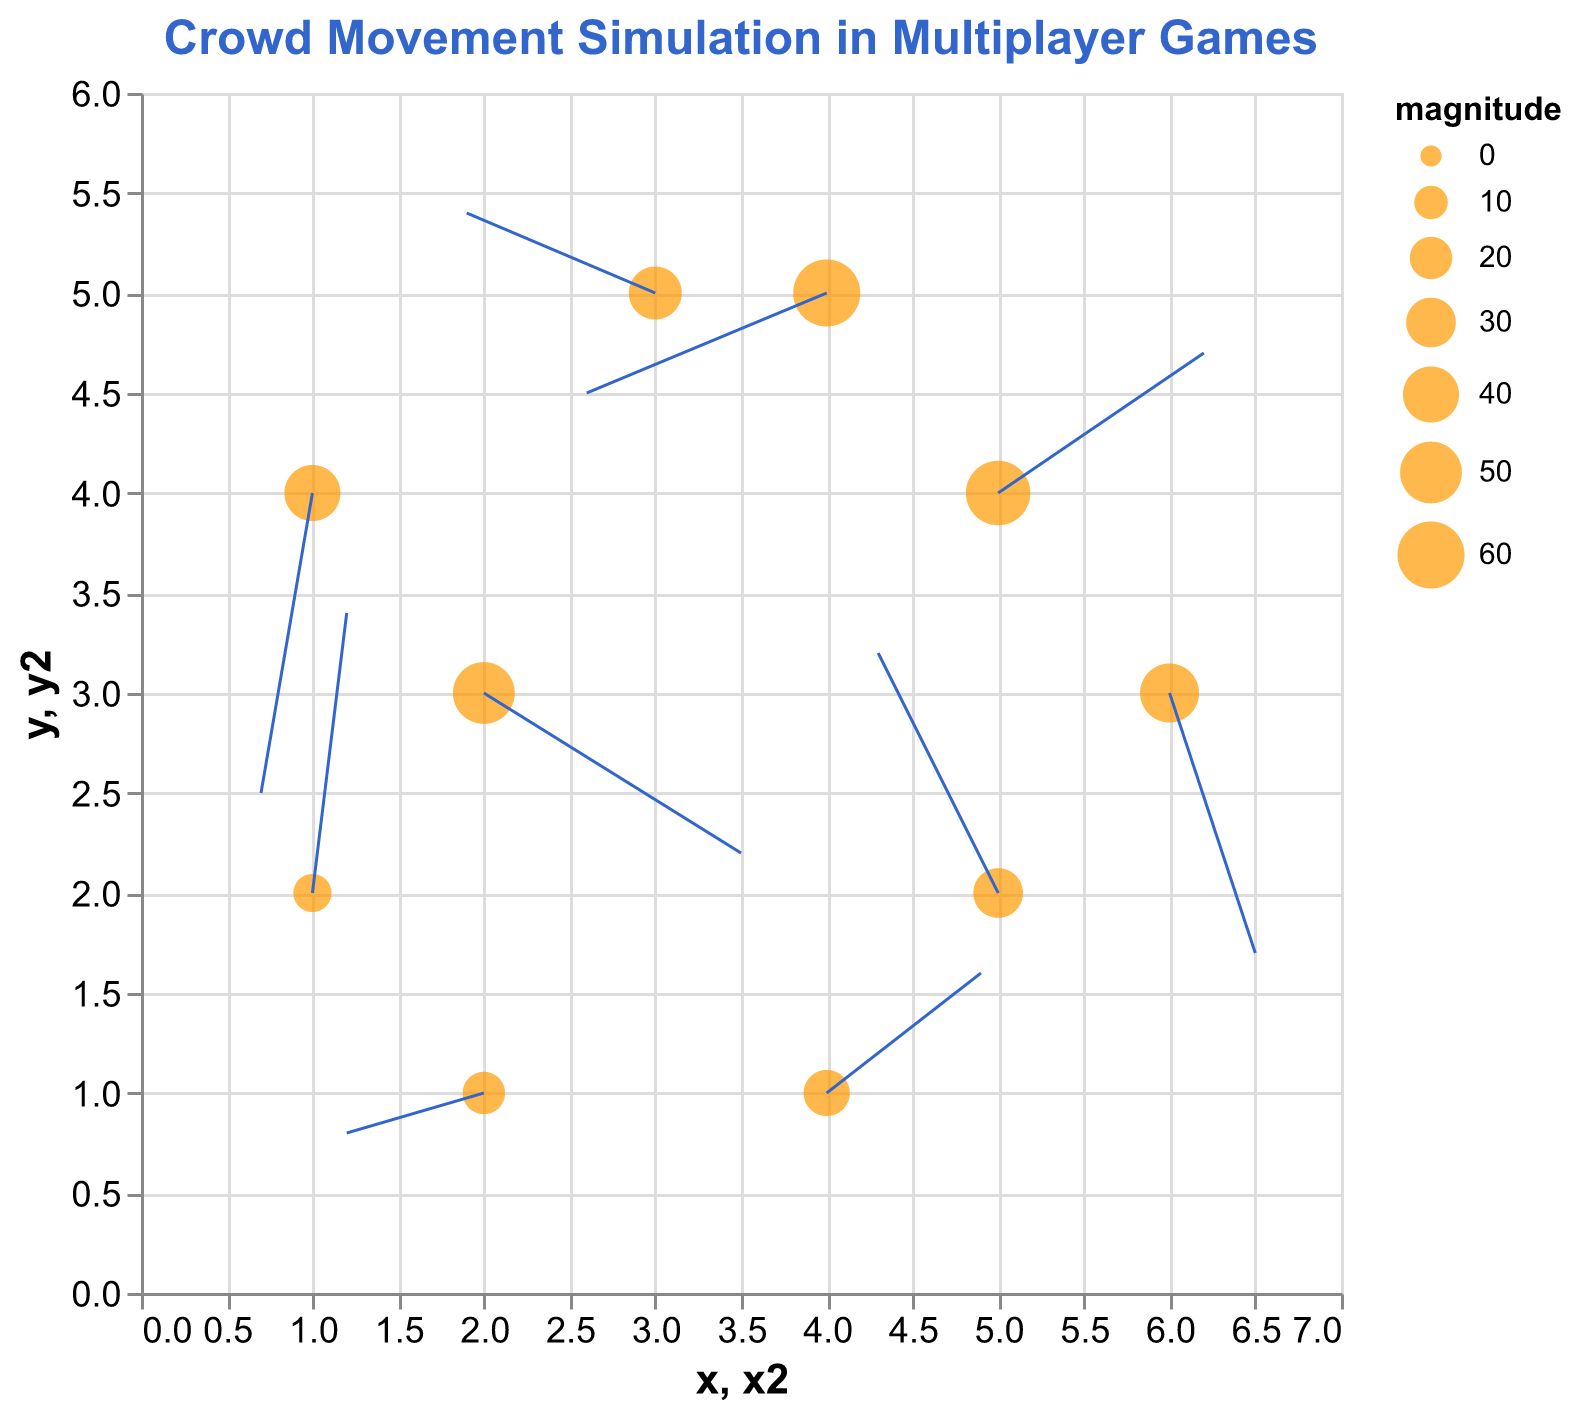what is the title of the plot? The title is usually displayed at the top of the plot and gives a quick summary of what the plot represents. In this case, it is clearly stated as "Crowd Movement Simulation in Multiplayer Games."
Answer: Crowd Movement Simulation in Multiplayer Games What are the scales of the x and y axes? The scales of the x and y axes are based on the data points' positions, as indicated by the ranges. The x-axis ranges from 0 to 7, and the y-axis ranges from 0 to 6.
Answer: The x-axis ranges from 0-7, and the y-axis ranges from 0-6 How many data points are plotted in the figure? By counting the number of (x, y) coordinates given in the data, we can determine that there are 10 data points plotted in the figure.
Answer: 10 Which data point has the largest magnitude, and what is its value? By examining the sizes of the points on the plot, we identify the largest point. The largest point corresponds to a magnitude of 60. Checking the data, the coordinates for this point are (4, 5).
Answer: The data point at (4, 5) has the largest magnitude, which is 60 What are the indicated velocities (u, v) at the data point (2, 3)? To find the velocities at (2, 3), look at the data associated with the coordinates. The values are u = 1.5 and v = -0.8.
Answer: u = 1.5, v = -0.8 How does the magnitude of the data point at (5, 4) compare to the point at (1, 4)? Checking the magnitudes of both points from the data, (5, 4) has a magnitude of 55, and (1, 4) has a magnitude of 40. Therefore, (5, 4) has a larger magnitude.
Answer: The magnitude at (5, 4) is larger Which point has the smallest x-component of velocity (u)? By comparing the x-component of velocity (u) values in the data, the smallest value of u is -1.4, which is at the point (4, 5).
Answer: The point (4, 5) has the smallest x-component of velocity What direction is the arrow at point (3, 5) pointing, and what are its velocity components? To determine the arrow's direction, look at the u and v values for the point (3, 5). The velocities are u = -1.1 and v = 0.4, indicating a leftward and slightly upward direction.
Answer: Leftward and slightly upward, u = -1.1, v = 0.4 Which data point has the highest y-component of velocity (v)? By examining all the v values, we see that the highest y-component of velocity is 1.4, which occurs at the point (1, 2).
Answer: The point (1, 2) has the highest y-component of velocity What is the average magnitude of all plotted points? To calculate the average magnitude: (50 + 30 + 40 + 25 + 35 + 45 + 20 + 55 + 15 + 60) / 10 = 37.5.
Answer: 37.5 